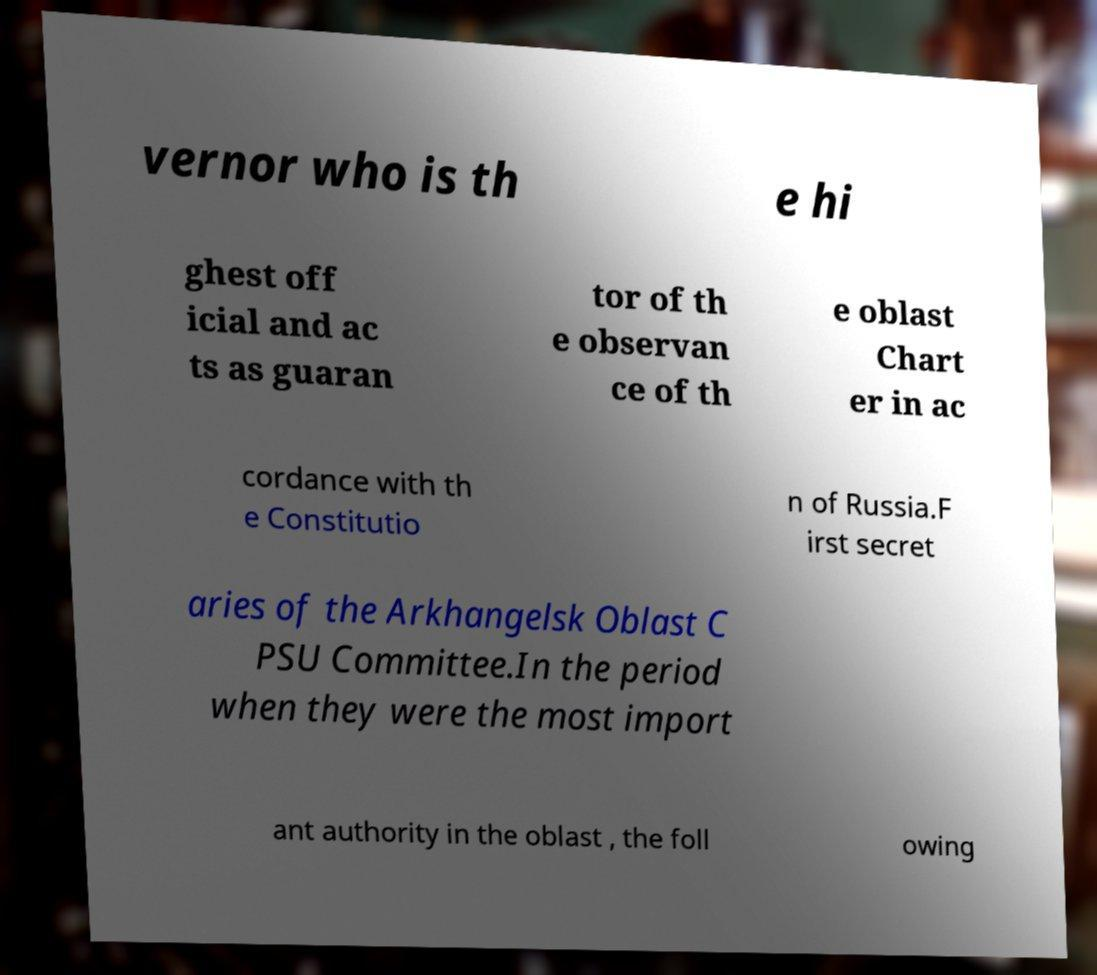Can you read and provide the text displayed in the image?This photo seems to have some interesting text. Can you extract and type it out for me? vernor who is th e hi ghest off icial and ac ts as guaran tor of th e observan ce of th e oblast Chart er in ac cordance with th e Constitutio n of Russia.F irst secret aries of the Arkhangelsk Oblast C PSU Committee.In the period when they were the most import ant authority in the oblast , the foll owing 